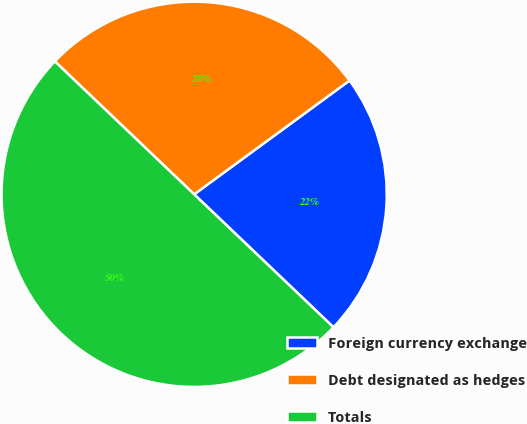Convert chart. <chart><loc_0><loc_0><loc_500><loc_500><pie_chart><fcel>Foreign currency exchange<fcel>Debt designated as hedges<fcel>Totals<nl><fcel>22.19%<fcel>27.81%<fcel>50.0%<nl></chart> 